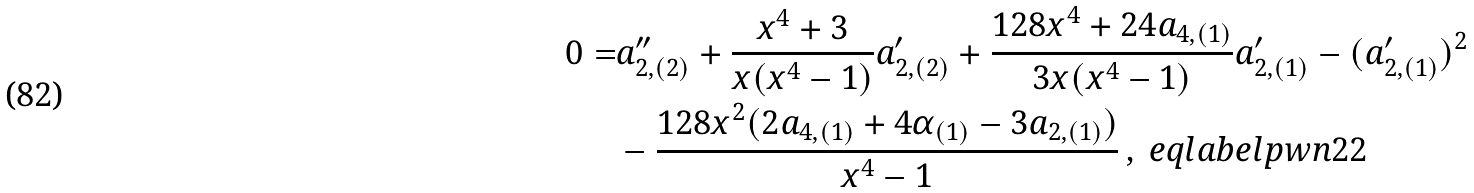<formula> <loc_0><loc_0><loc_500><loc_500>0 = & a _ { 2 , ( 2 ) } ^ { \prime \prime } + \frac { x ^ { 4 } + 3 } { x ( x ^ { 4 } - 1 ) } a _ { 2 , ( 2 ) } ^ { \prime } + \frac { 1 2 8 x ^ { 4 } + 2 4 a _ { 4 , ( 1 ) } } { 3 x ( x ^ { 4 } - 1 ) } a _ { 2 , ( 1 ) } ^ { \prime } - ( a _ { 2 , ( 1 ) } ^ { \prime } ) ^ { 2 } \\ & - \frac { 1 2 8 x ^ { 2 } ( 2 a _ { 4 , ( 1 ) } + 4 \alpha _ { ( 1 ) } - 3 a _ { 2 , ( 1 ) } ) } { x ^ { 4 } - 1 } \, , \ e q l a b e l { p w n 2 2 }</formula> 